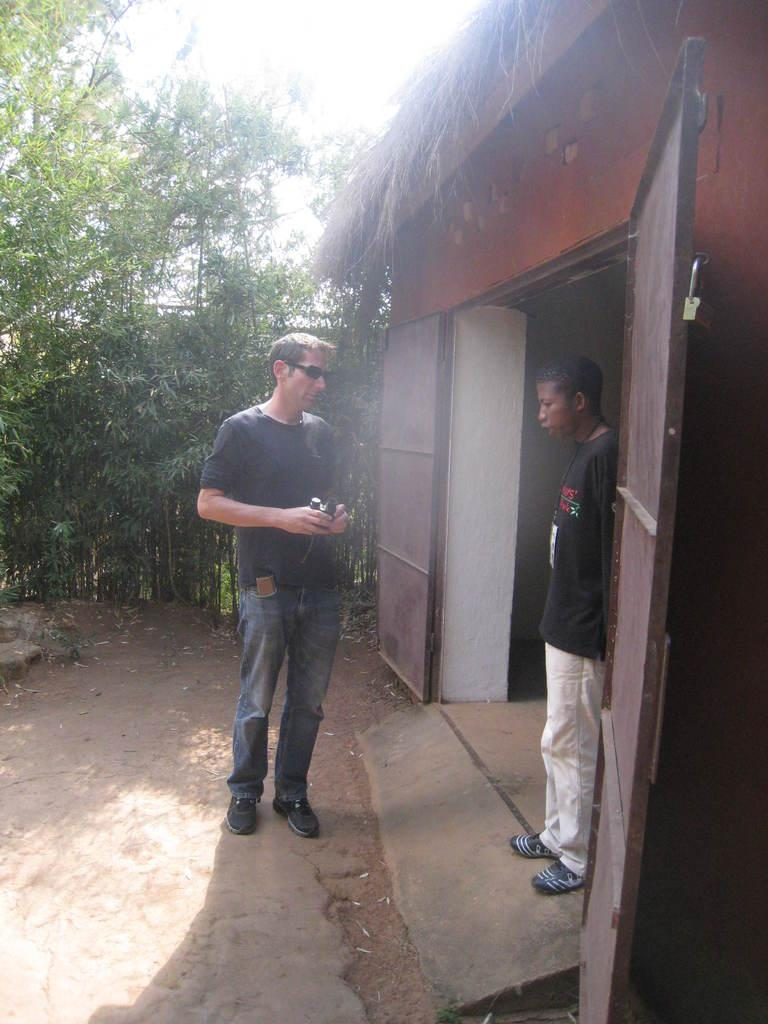What type of vegetation is on the left side of the image? There are trees on the left side of the image. What can be seen in the middle of the image? There are two persons in the middle of the image. What is located on the right side of the image? There is a door on the right side of the image. What is visible at the top of the image? The sky is visible at the top of the image. How many forks are lying on the ground in the image? There are no forks present in the image. What type of pizzas are being served to the two persons in the image? There are no pizzas present in the image. 